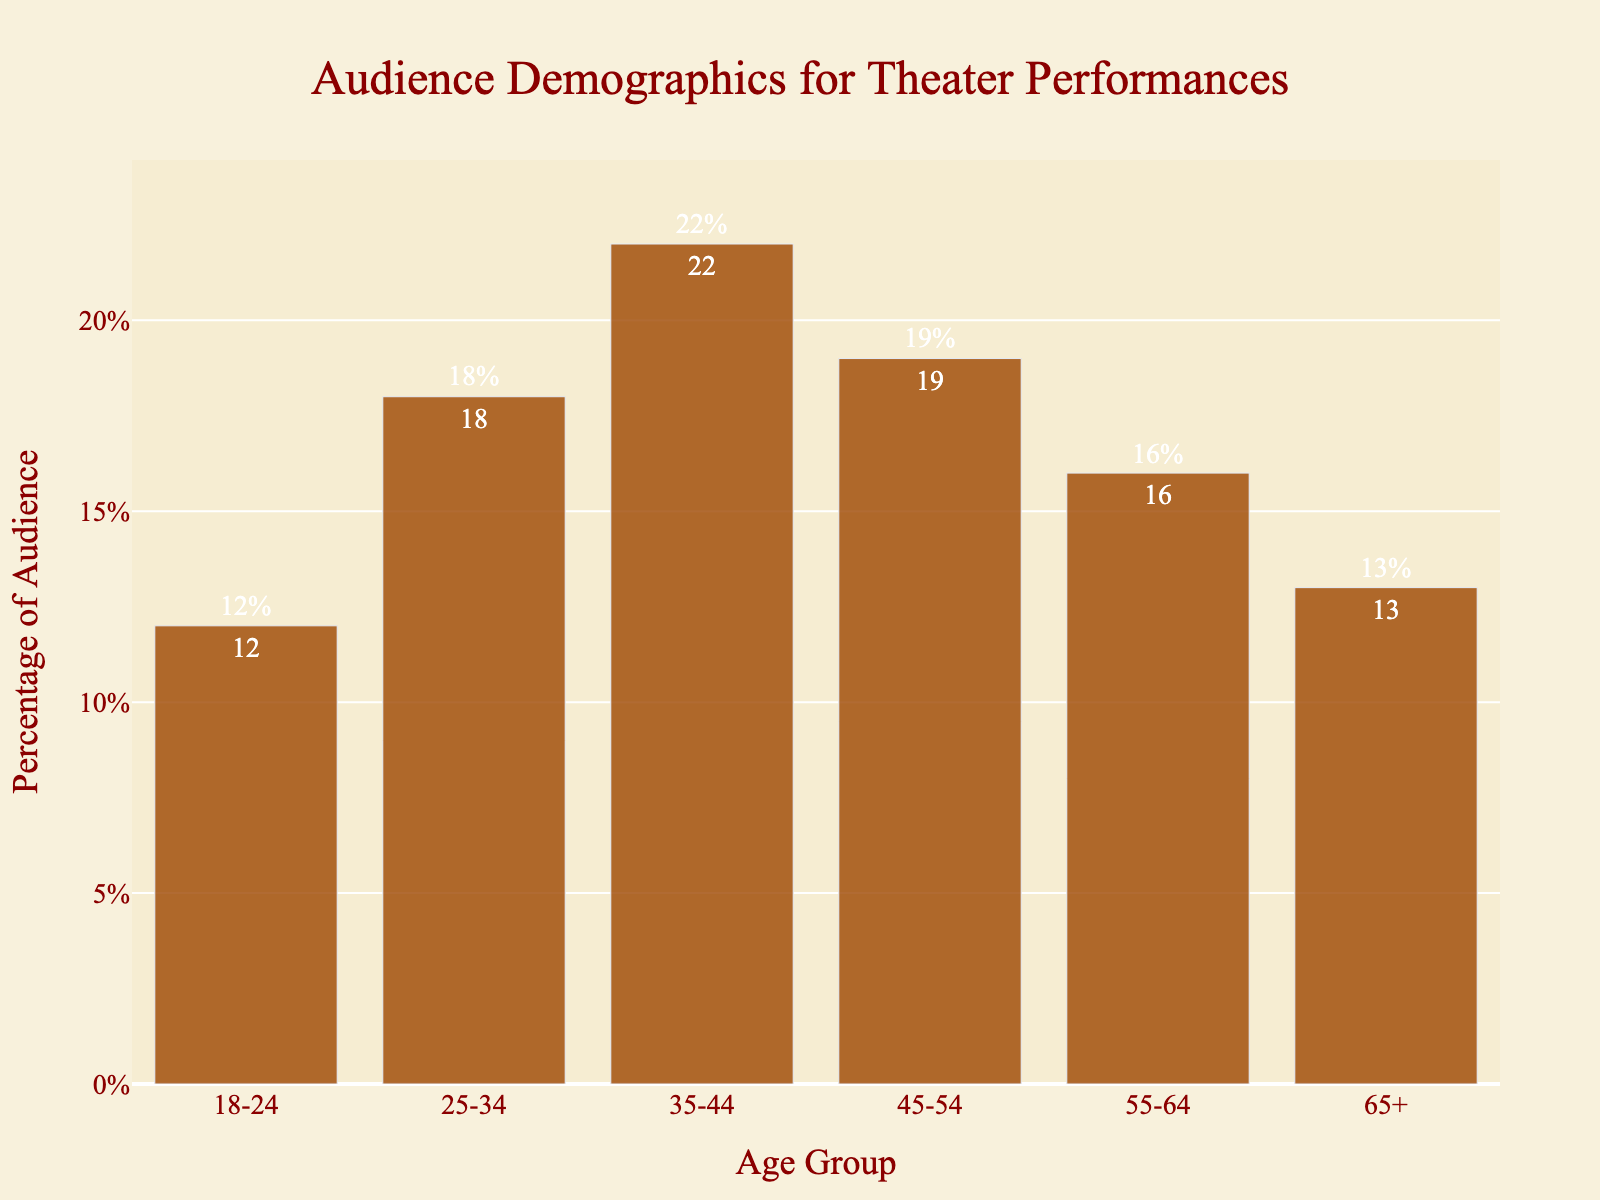What's the largest age group in the audience? The bar representing the 35-44 age group is the tallest, indicating it has the highest percentage.
Answer: 35-44 Which age group has the smallest audience percentage? By inspecting the shortest bar, the 18-24 age group has the smallest percentage.
Answer: 18-24 How does the percentage of the 45-54 age group compare to the 65+ age group? The bar for the 45-54 age group is taller than the bar for the 65+ age group, indicating a larger percentage.
Answer: 45-54 is greater than 65+ What is the total percentage of the audience for ages above 44? Sum the percentages of 45-54, 55-64, and 65+ age groups: 19% + 16% + 13% = 48%.
Answer: 48% What’s the average percentage of the age groups from 25-34 to 65+? Add the percentages of the 25-34, 35-44, 45-54, 55-64, and 65+ age groups and divide by 5: (18 + 22 + 19 + 16 + 13) / 5 = 17.6%.
Answer: 17.6% Which age groups make up more than 15% of the audience individually? The bars for 25-34, 35-44, 45-54, and 55-64 age groups exceed 15% in height.
Answer: 25-34, 35-44, 45-54, 55-64 What is the combined percentage for the 18-24 and 55-64 age groups? Add the percentages for 18-24 and 55-64: 12% + 16% = 28%.
Answer: 28% By how much does the percentage of the 35-44 age group exceed the 18-24 age group? Subtract the percentage for 18-24 from that of 35-44: 22% - 12% = 10%.
Answer: 10% Which age group has an audience percentage closest to 20%? The 45-54 age group has a percentage closest to 20%, with 19%.
Answer: 45-54 What are the visual attributes of the bars representing age groups 35-44 and 55-64? The bar for 35-44 is taller and darker in color compared to the bar for 55-64, which is shorter. Both are in shades of red.
Answer: 35-44 is taller and darker; 55-64 is shorter and lighter 